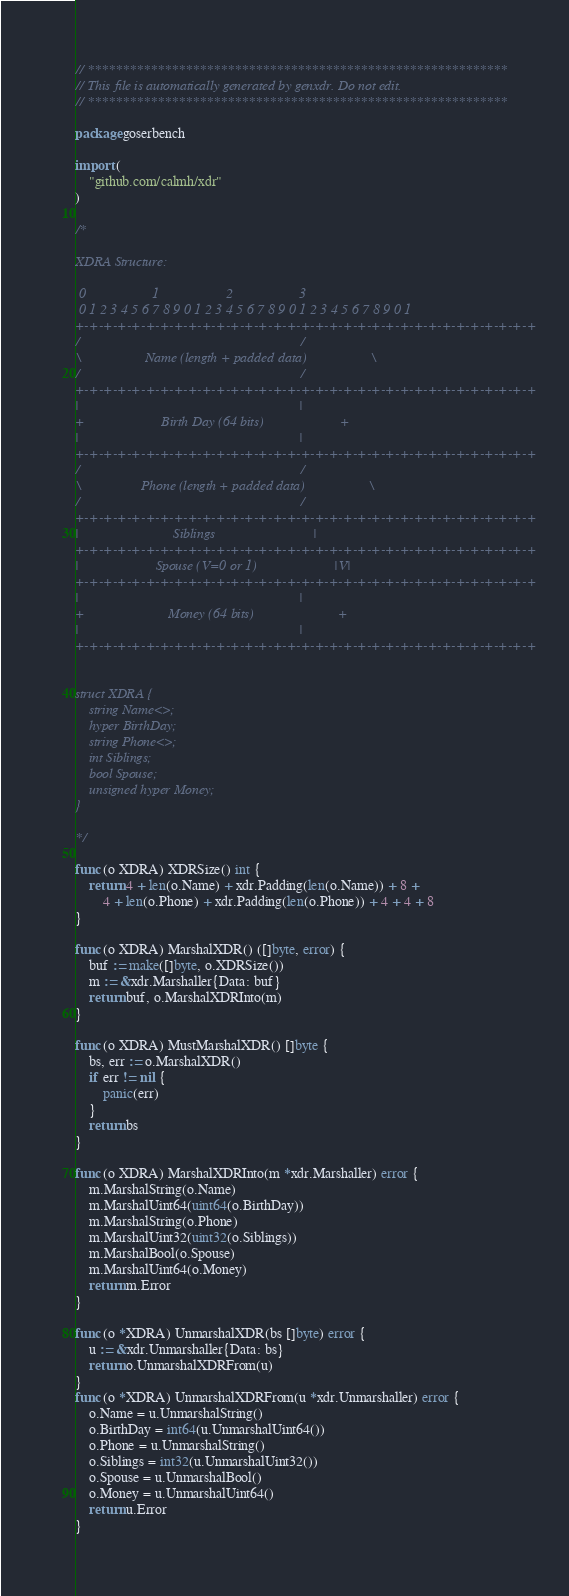Convert code to text. <code><loc_0><loc_0><loc_500><loc_500><_Go_>// ************************************************************
// This file is automatically generated by genxdr. Do not edit.
// ************************************************************

package goserbench

import (
	"github.com/calmh/xdr"
)

/*

XDRA Structure:

 0                   1                   2                   3
 0 1 2 3 4 5 6 7 8 9 0 1 2 3 4 5 6 7 8 9 0 1 2 3 4 5 6 7 8 9 0 1
+-+-+-+-+-+-+-+-+-+-+-+-+-+-+-+-+-+-+-+-+-+-+-+-+-+-+-+-+-+-+-+-+
/                                                               /
\                  Name (length + padded data)                  \
/                                                               /
+-+-+-+-+-+-+-+-+-+-+-+-+-+-+-+-+-+-+-+-+-+-+-+-+-+-+-+-+-+-+-+-+
|                                                               |
+                      Birth Day (64 bits)                      +
|                                                               |
+-+-+-+-+-+-+-+-+-+-+-+-+-+-+-+-+-+-+-+-+-+-+-+-+-+-+-+-+-+-+-+-+
/                                                               /
\                 Phone (length + padded data)                  \
/                                                               /
+-+-+-+-+-+-+-+-+-+-+-+-+-+-+-+-+-+-+-+-+-+-+-+-+-+-+-+-+-+-+-+-+
|                           Siblings                            |
+-+-+-+-+-+-+-+-+-+-+-+-+-+-+-+-+-+-+-+-+-+-+-+-+-+-+-+-+-+-+-+-+
|                      Spouse (V=0 or 1)                      |V|
+-+-+-+-+-+-+-+-+-+-+-+-+-+-+-+-+-+-+-+-+-+-+-+-+-+-+-+-+-+-+-+-+
|                                                               |
+                        Money (64 bits)                        +
|                                                               |
+-+-+-+-+-+-+-+-+-+-+-+-+-+-+-+-+-+-+-+-+-+-+-+-+-+-+-+-+-+-+-+-+


struct XDRA {
	string Name<>;
	hyper BirthDay;
	string Phone<>;
	int Siblings;
	bool Spouse;
	unsigned hyper Money;
}

*/

func (o XDRA) XDRSize() int {
	return 4 + len(o.Name) + xdr.Padding(len(o.Name)) + 8 +
		4 + len(o.Phone) + xdr.Padding(len(o.Phone)) + 4 + 4 + 8
}

func (o XDRA) MarshalXDR() ([]byte, error) {
	buf := make([]byte, o.XDRSize())
	m := &xdr.Marshaller{Data: buf}
	return buf, o.MarshalXDRInto(m)
}

func (o XDRA) MustMarshalXDR() []byte {
	bs, err := o.MarshalXDR()
	if err != nil {
		panic(err)
	}
	return bs
}

func (o XDRA) MarshalXDRInto(m *xdr.Marshaller) error {
	m.MarshalString(o.Name)
	m.MarshalUint64(uint64(o.BirthDay))
	m.MarshalString(o.Phone)
	m.MarshalUint32(uint32(o.Siblings))
	m.MarshalBool(o.Spouse)
	m.MarshalUint64(o.Money)
	return m.Error
}

func (o *XDRA) UnmarshalXDR(bs []byte) error {
	u := &xdr.Unmarshaller{Data: bs}
	return o.UnmarshalXDRFrom(u)
}
func (o *XDRA) UnmarshalXDRFrom(u *xdr.Unmarshaller) error {
	o.Name = u.UnmarshalString()
	o.BirthDay = int64(u.UnmarshalUint64())
	o.Phone = u.UnmarshalString()
	o.Siblings = int32(u.UnmarshalUint32())
	o.Spouse = u.UnmarshalBool()
	o.Money = u.UnmarshalUint64()
	return u.Error
}
</code> 